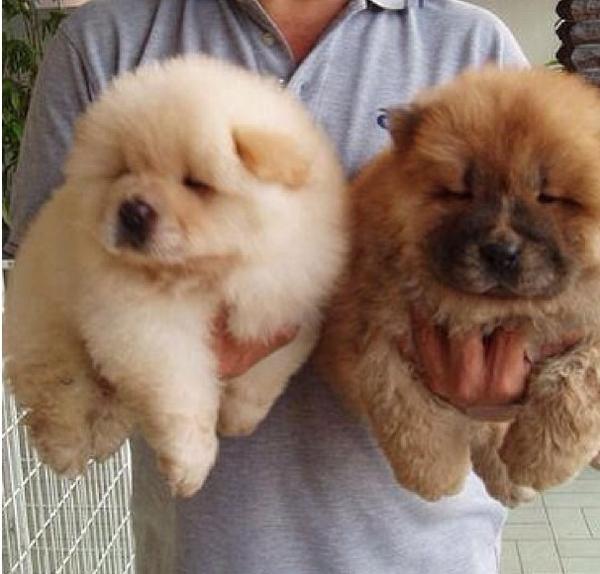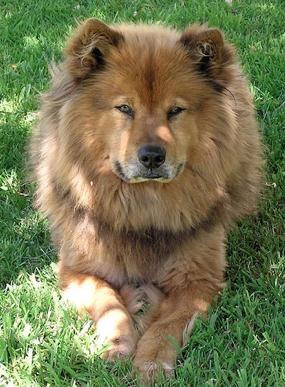The first image is the image on the left, the second image is the image on the right. Assess this claim about the two images: "A man in a light blue shirt is holding two puppies.". Correct or not? Answer yes or no. Yes. 